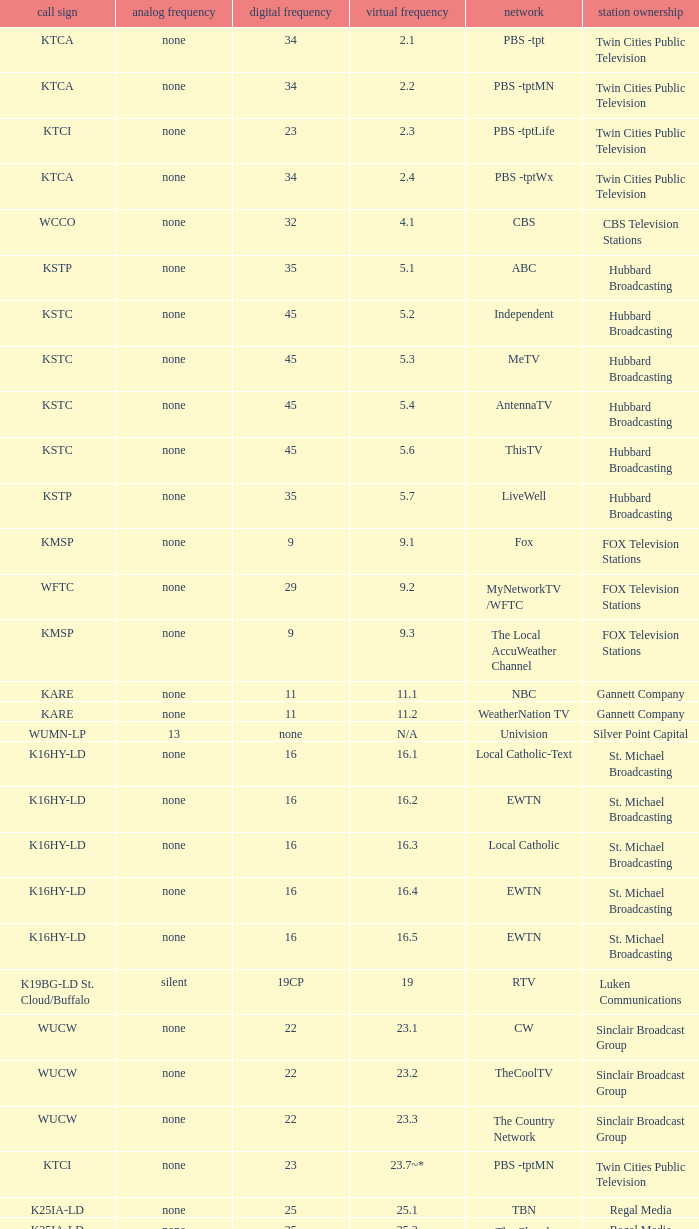Call sign of k43hb-ld is what virtual channel? 43.1. 